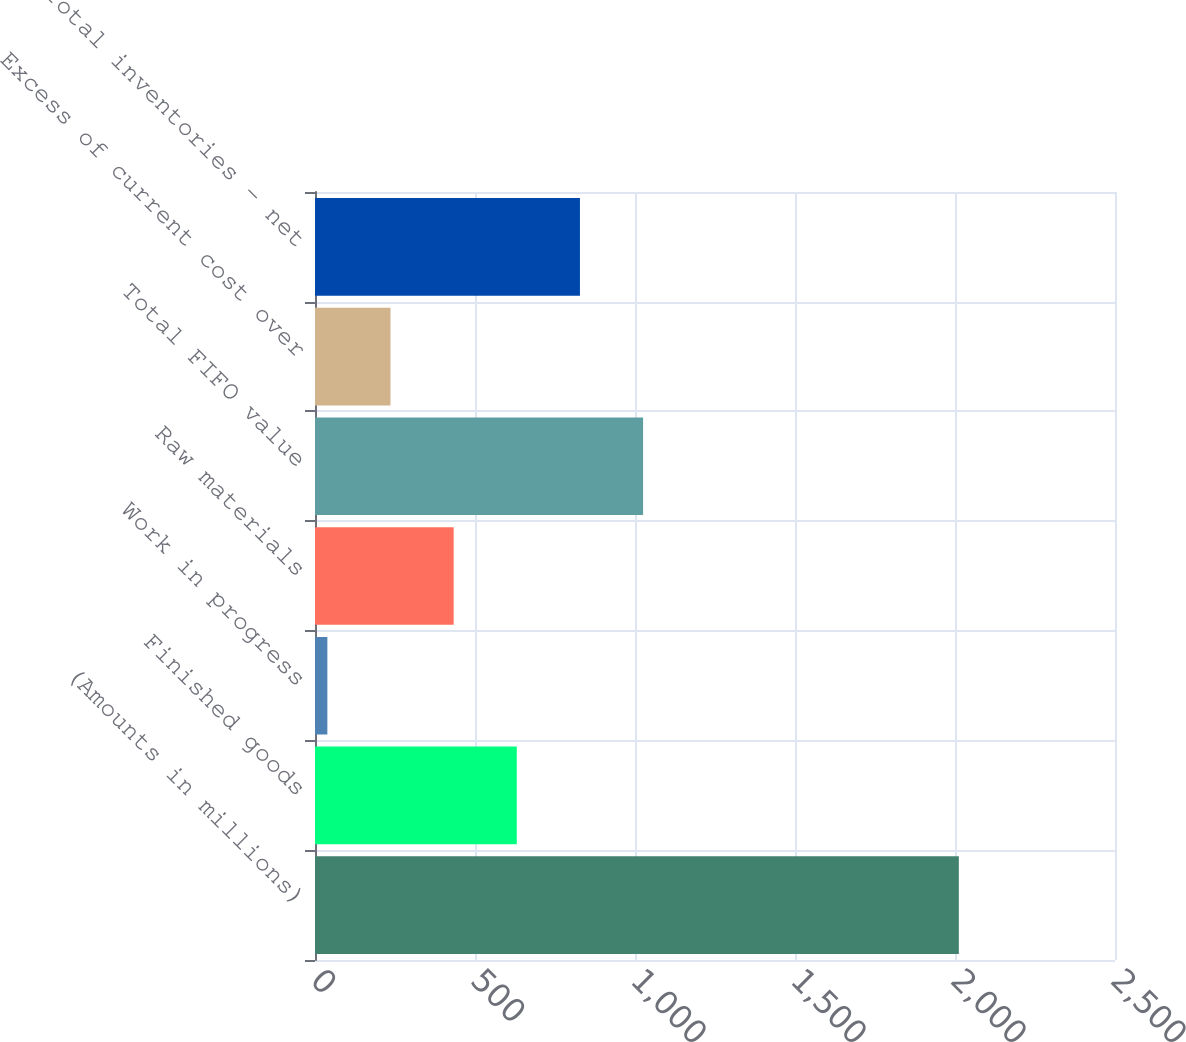Convert chart to OTSL. <chart><loc_0><loc_0><loc_500><loc_500><bar_chart><fcel>(Amounts in millions)<fcel>Finished goods<fcel>Work in progress<fcel>Raw materials<fcel>Total FIFO value<fcel>Excess of current cost over<fcel>Total inventories - net<nl><fcel>2012<fcel>630.62<fcel>38.6<fcel>433.28<fcel>1025.3<fcel>235.94<fcel>827.96<nl></chart> 